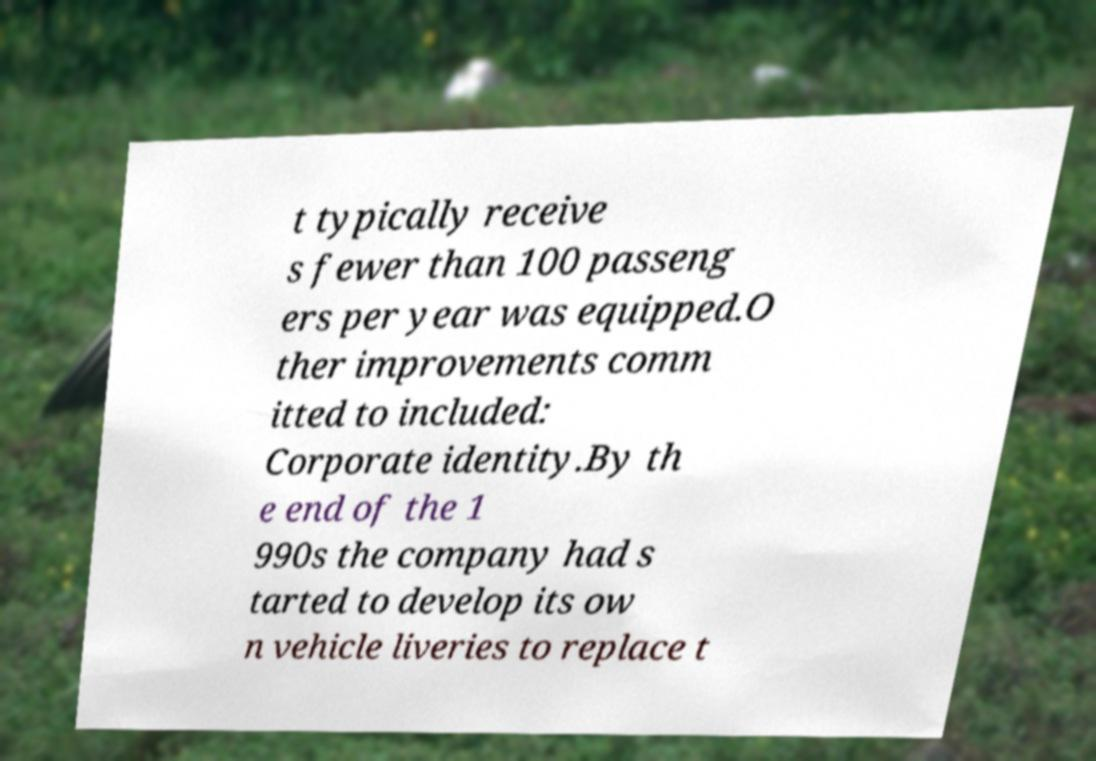Please read and relay the text visible in this image. What does it say? t typically receive s fewer than 100 passeng ers per year was equipped.O ther improvements comm itted to included: Corporate identity.By th e end of the 1 990s the company had s tarted to develop its ow n vehicle liveries to replace t 